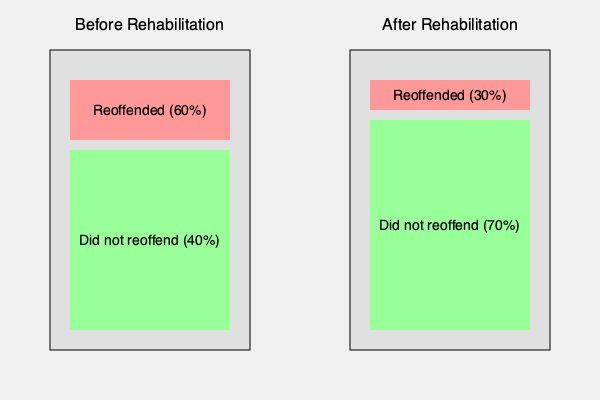Based on the before-and-after diagrams depicting the effectiveness of a rehabilitation program, what is the percentage point decrease in reoffending rates? To determine the percentage point decrease in reoffending rates, we need to follow these steps:

1. Identify the reoffending rate before rehabilitation:
   - The "Before Rehabilitation" diagram shows 60% reoffended.

2. Identify the reoffending rate after rehabilitation:
   - The "After Rehabilitation" diagram shows 30% reoffended.

3. Calculate the difference between the two rates:
   - Percentage point decrease = Before rate - After rate
   - Percentage point decrease = 60% - 30% = 30 percentage points

The rehabilitation program resulted in a 30 percentage point decrease in reoffending rates.

This significant reduction demonstrates the effectiveness of the rehabilitation program in reducing recidivism, which is crucial information for a legislator advocating for criminal justice reform.
Answer: 30 percentage points 